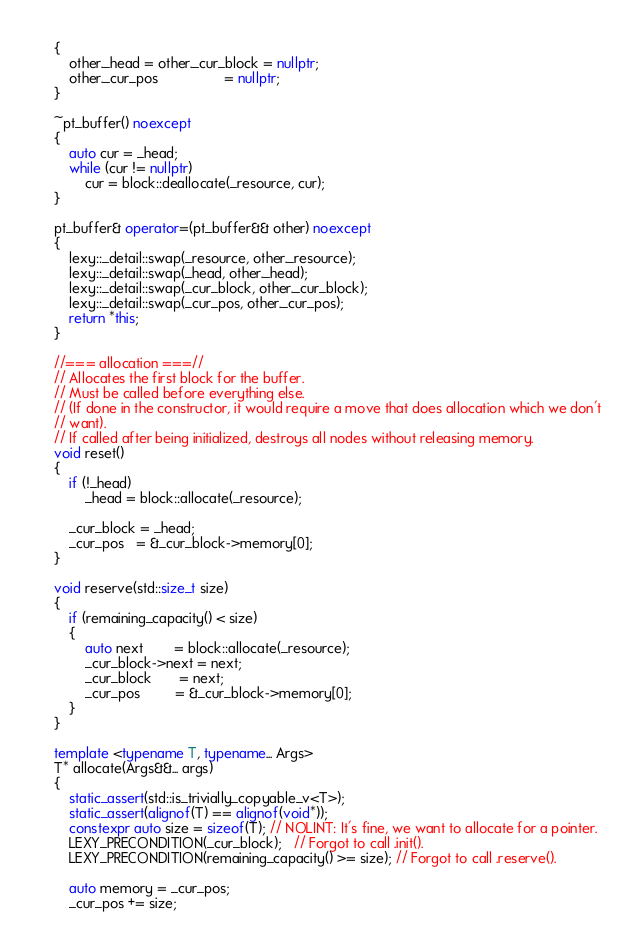Convert code to text. <code><loc_0><loc_0><loc_500><loc_500><_C++_>    {
        other._head = other._cur_block = nullptr;
        other._cur_pos                 = nullptr;
    }

    ~pt_buffer() noexcept
    {
        auto cur = _head;
        while (cur != nullptr)
            cur = block::deallocate(_resource, cur);
    }

    pt_buffer& operator=(pt_buffer&& other) noexcept
    {
        lexy::_detail::swap(_resource, other._resource);
        lexy::_detail::swap(_head, other._head);
        lexy::_detail::swap(_cur_block, other._cur_block);
        lexy::_detail::swap(_cur_pos, other._cur_pos);
        return *this;
    }

    //=== allocation ===//
    // Allocates the first block for the buffer.
    // Must be called before everything else.
    // (If done in the constructor, it would require a move that does allocation which we don't
    // want).
    // If called after being initialized, destroys all nodes without releasing memory.
    void reset()
    {
        if (!_head)
            _head = block::allocate(_resource);

        _cur_block = _head;
        _cur_pos   = &_cur_block->memory[0];
    }

    void reserve(std::size_t size)
    {
        if (remaining_capacity() < size)
        {
            auto next        = block::allocate(_resource);
            _cur_block->next = next;
            _cur_block       = next;
            _cur_pos         = &_cur_block->memory[0];
        }
    }

    template <typename T, typename... Args>
    T* allocate(Args&&... args)
    {
        static_assert(std::is_trivially_copyable_v<T>);
        static_assert(alignof(T) == alignof(void*));
        constexpr auto size = sizeof(T); // NOLINT: It's fine, we want to allocate for a pointer.
        LEXY_PRECONDITION(_cur_block);   // Forgot to call .init().
        LEXY_PRECONDITION(remaining_capacity() >= size); // Forgot to call .reserve().

        auto memory = _cur_pos;
        _cur_pos += size;</code> 